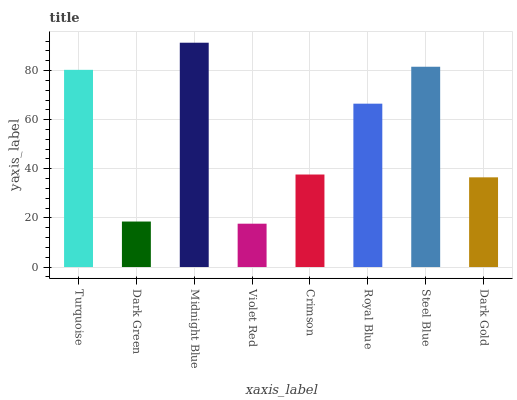Is Dark Green the minimum?
Answer yes or no. No. Is Dark Green the maximum?
Answer yes or no. No. Is Turquoise greater than Dark Green?
Answer yes or no. Yes. Is Dark Green less than Turquoise?
Answer yes or no. Yes. Is Dark Green greater than Turquoise?
Answer yes or no. No. Is Turquoise less than Dark Green?
Answer yes or no. No. Is Royal Blue the high median?
Answer yes or no. Yes. Is Crimson the low median?
Answer yes or no. Yes. Is Turquoise the high median?
Answer yes or no. No. Is Violet Red the low median?
Answer yes or no. No. 